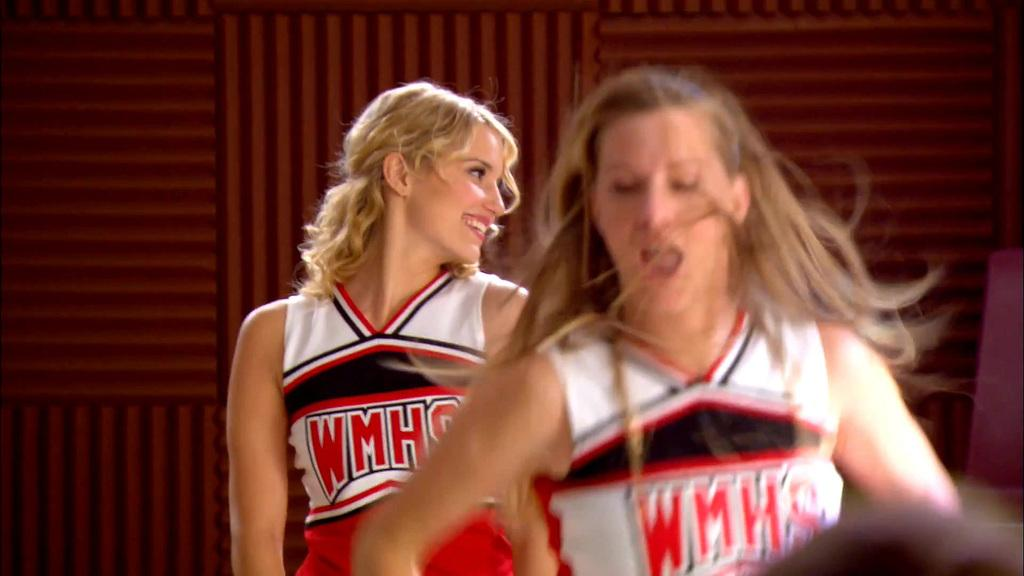<image>
Relay a brief, clear account of the picture shown. two girls cheering that have WMHS on the front of their shirt. 